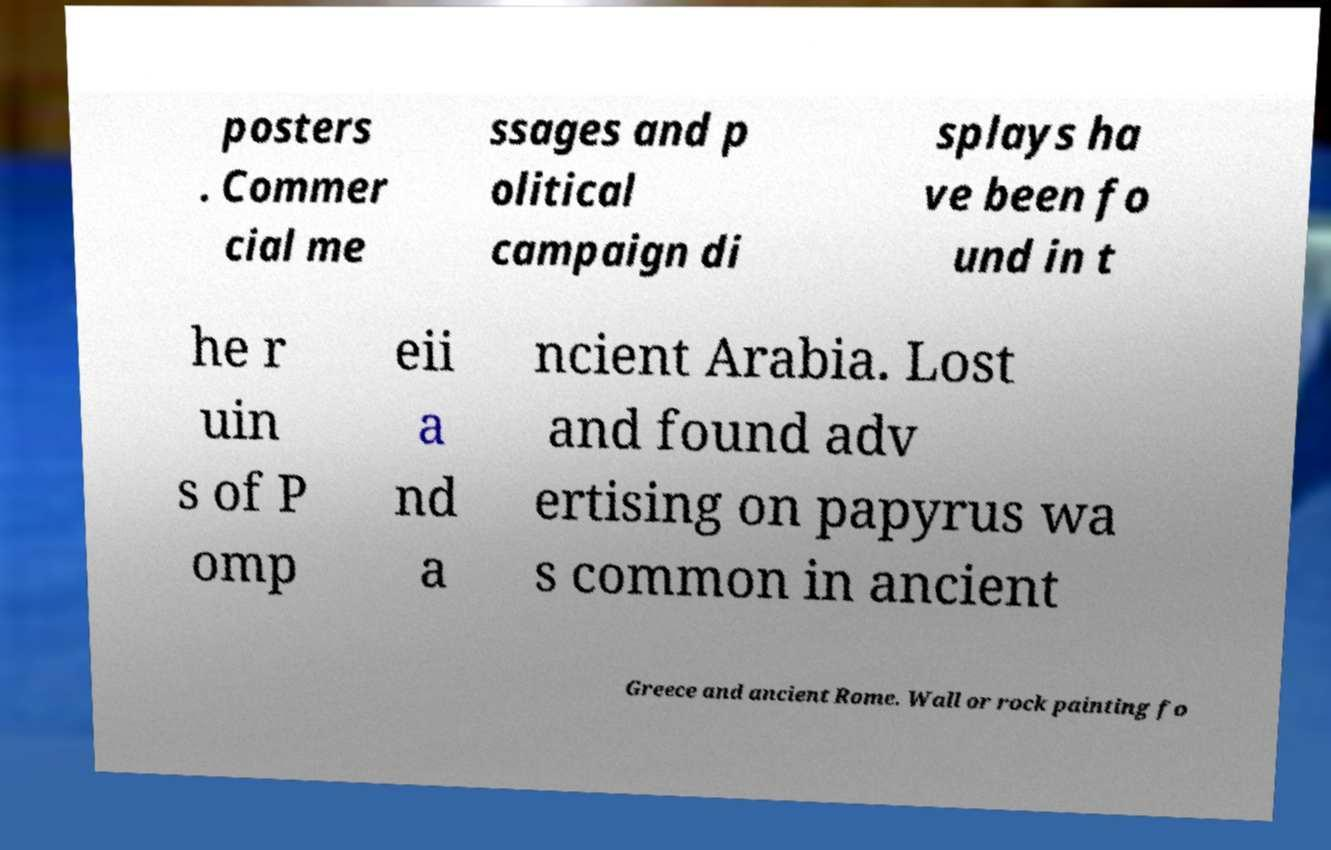There's text embedded in this image that I need extracted. Can you transcribe it verbatim? posters . Commer cial me ssages and p olitical campaign di splays ha ve been fo und in t he r uin s of P omp eii a nd a ncient Arabia. Lost and found adv ertising on papyrus wa s common in ancient Greece and ancient Rome. Wall or rock painting fo 